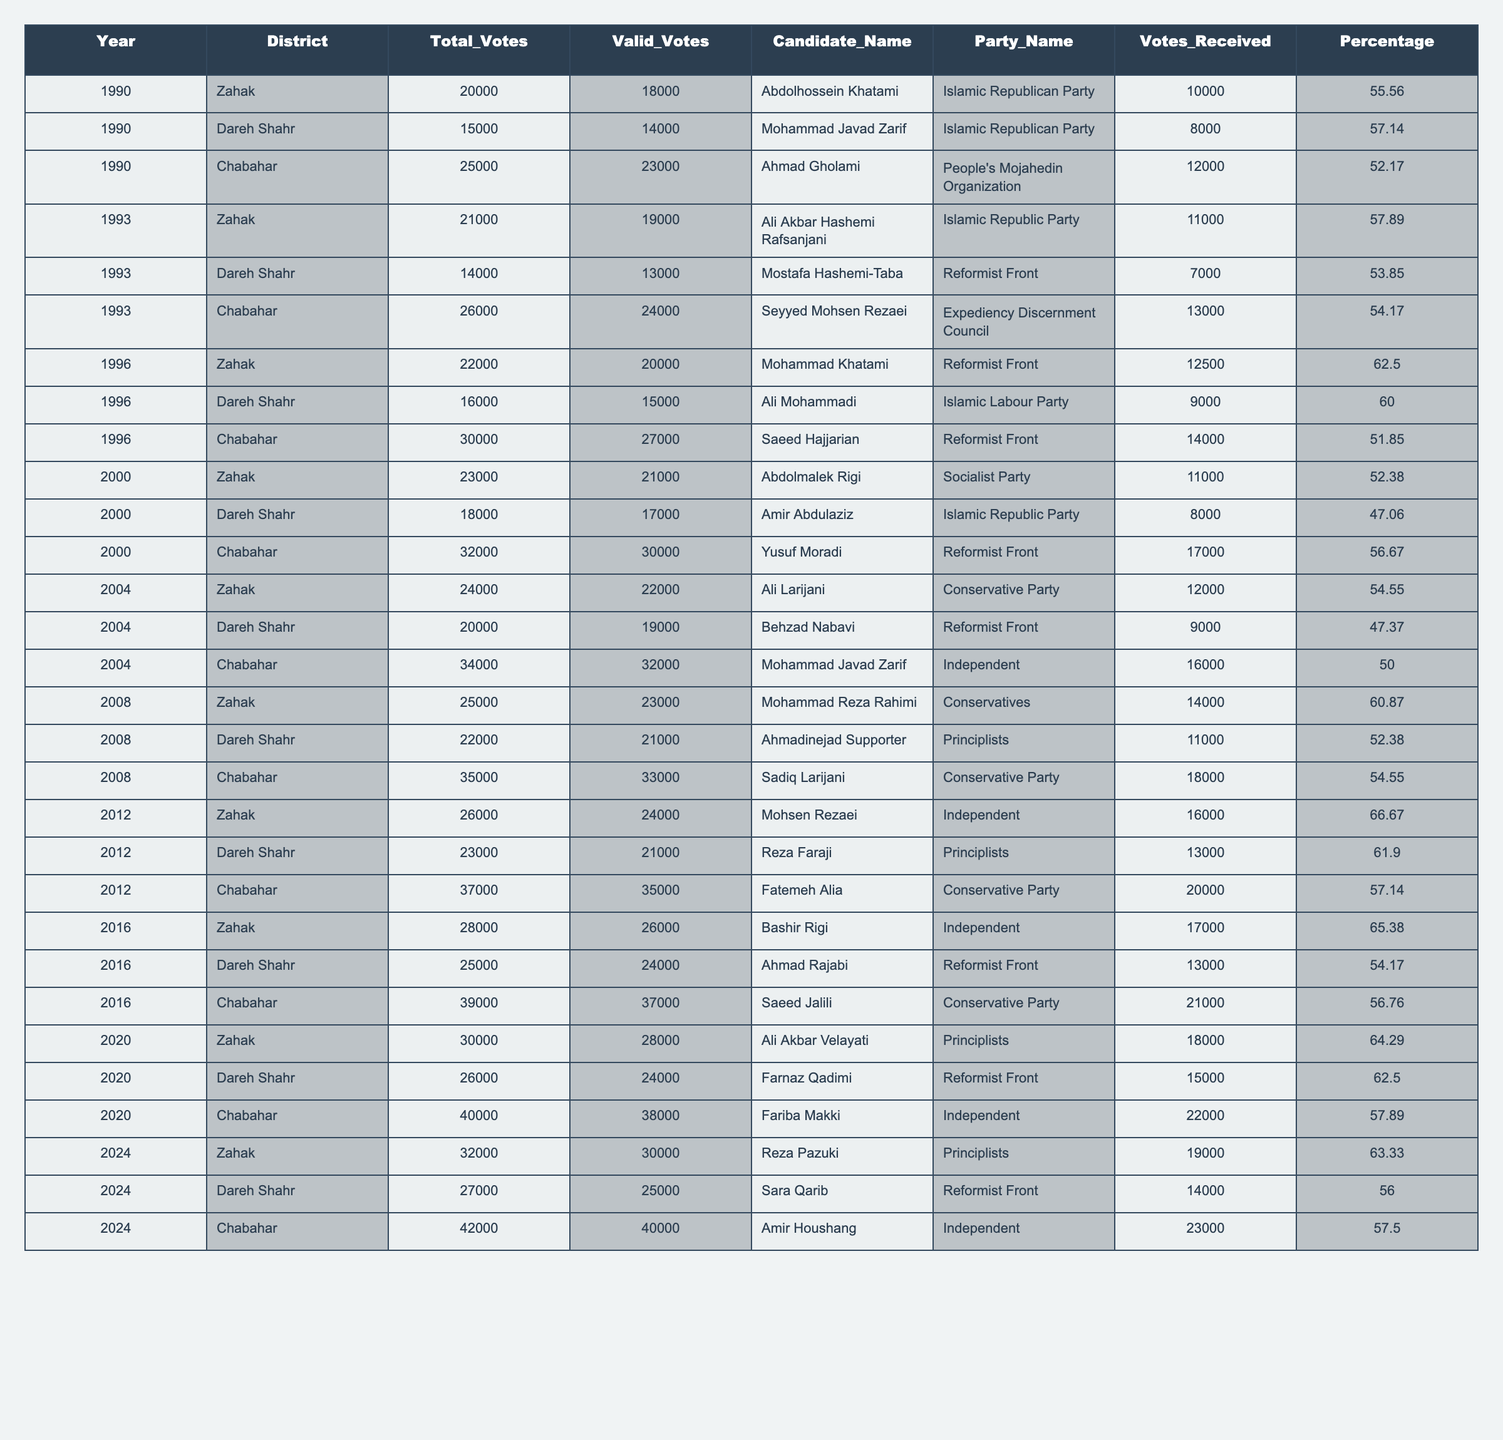What was the winning candidate's name in Chabahar in 2020? Referring to the 2020 row for Chabahar, the candidate listed is Fariba Makki.
Answer: Fariba Makki Which party had the highest percentage of votes in Zahak in 1996? In Zahak in 1996, Mohammad Khatami from the Reformist Front received 62.50% of the valid votes, which is the highest in that year for this district.
Answer: Reformist Front How many valid votes did Dareh Shahr receive in 2012? The row for Dareh Shahr in 2012 indicates that there were 21,000 valid votes.
Answer: 21000 Was there a candidate from the Socialist Party in the elections in 2000? Abdolmalek Rigi is listed as the candidate from the Socialist Party in Zahak in 2000.
Answer: Yes What is the average percentage of votes received by candidates in Chabahar from 1990 to 2024? To calculate the average percentage, add the percentages: (52.17 + 54.17 + 51.85 + 56.67 + 50.00 + 54.55 + 57.14 + 56.76 + 57.89 + 57.50) =  553.70, then divide by 10 to get the average: 553.70/10 = 55.37.
Answer: 55.37 How many total votes were cast in Zahak across all years from 1990 to 2024? Summing all the total votes for Zahak: (20000 + 21000 + 22000 + 23000 + 24000 + 25000 + 26000 + 28000 + 30000 + 32000) = 237000.
Answer: 237000 Which candidate received the most votes in Chabahar in 2024? The row for Chabahar in 2024 lists Amir Houshang with 23,000 votes, which is the highest for that year.
Answer: Amir Houshang Did any candidate from the Independent party win in Zahak from 2000 to 2024? Yes, the only time an Independent candidate won in Zahak during this period was Mohsen Rezaei in the 2012 election, with 66.67%.
Answer: Yes 